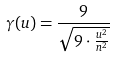Convert formula to latex. <formula><loc_0><loc_0><loc_500><loc_500>\gamma ( u ) = \frac { 9 } { \sqrt { 9 \cdot \frac { u ^ { 2 } } { n ^ { 2 } } } }</formula> 